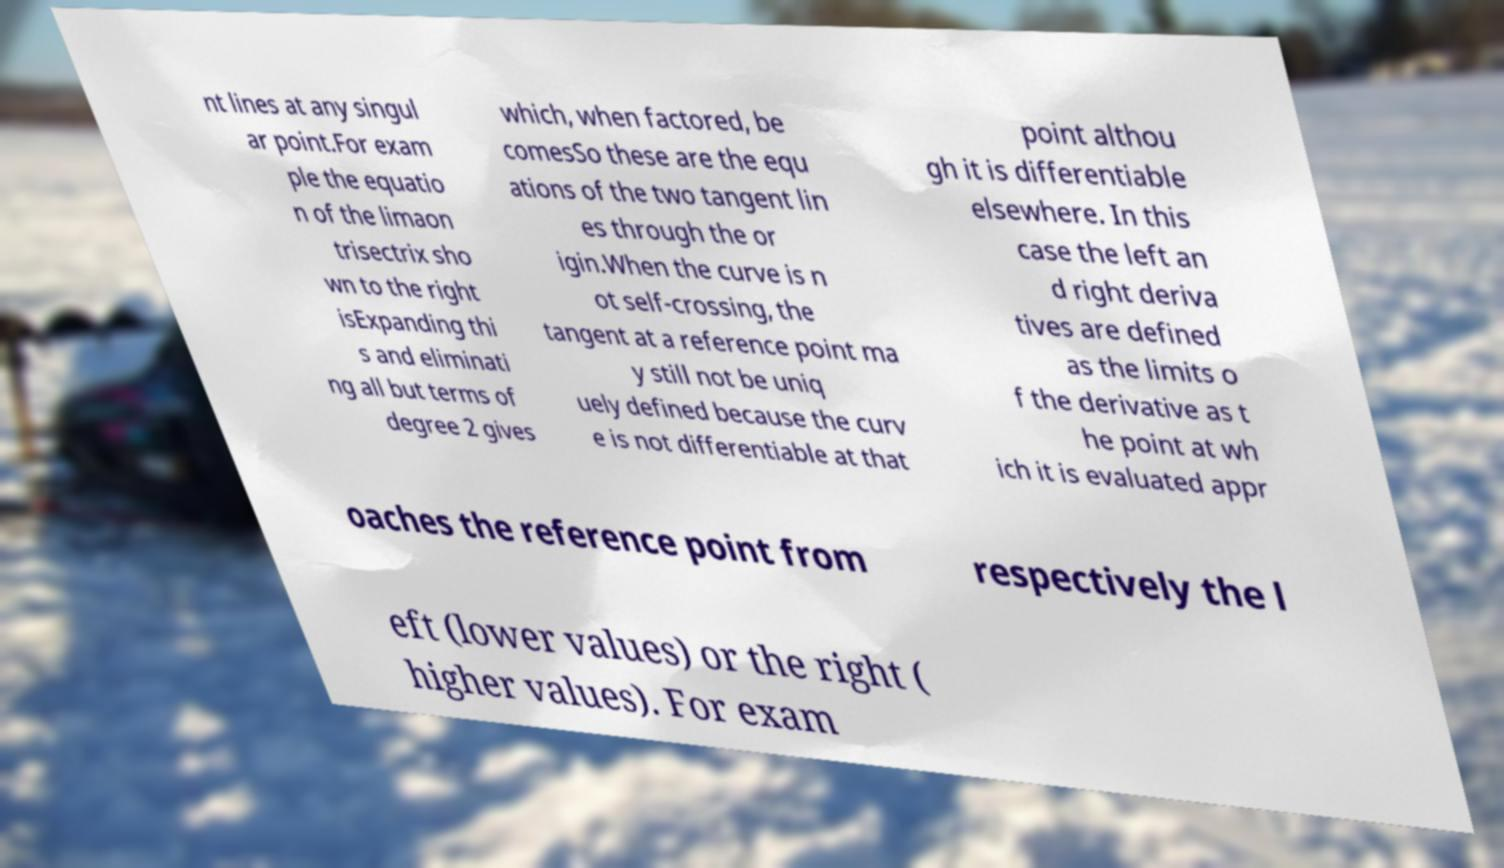For documentation purposes, I need the text within this image transcribed. Could you provide that? nt lines at any singul ar point.For exam ple the equatio n of the limaon trisectrix sho wn to the right isExpanding thi s and eliminati ng all but terms of degree 2 gives which, when factored, be comesSo these are the equ ations of the two tangent lin es through the or igin.When the curve is n ot self-crossing, the tangent at a reference point ma y still not be uniq uely defined because the curv e is not differentiable at that point althou gh it is differentiable elsewhere. In this case the left an d right deriva tives are defined as the limits o f the derivative as t he point at wh ich it is evaluated appr oaches the reference point from respectively the l eft (lower values) or the right ( higher values). For exam 